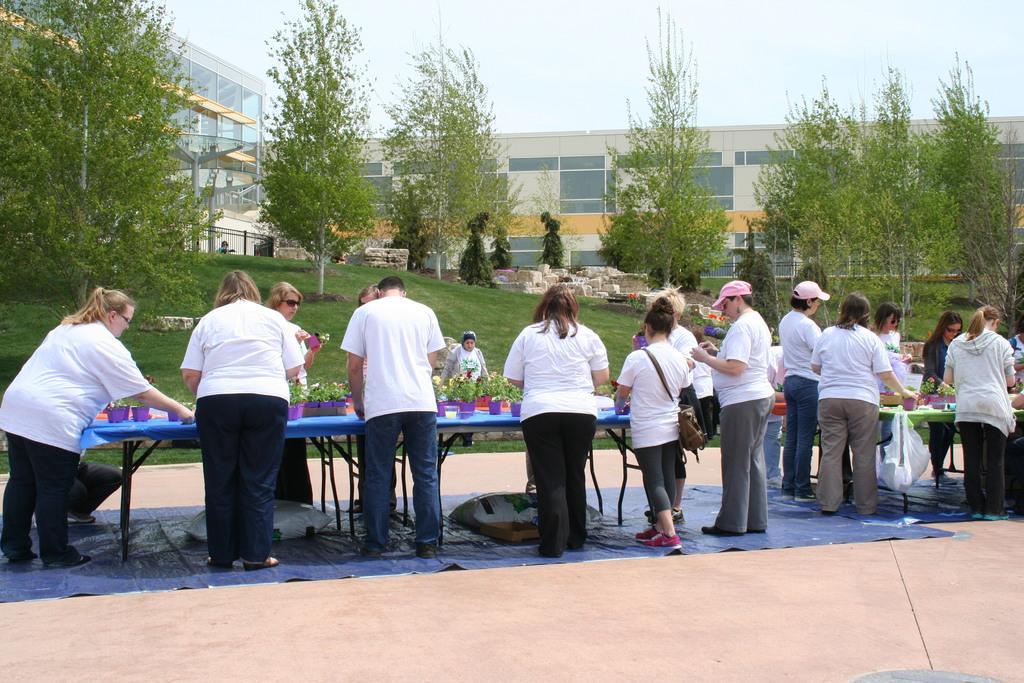Please provide a concise description of this image. In this image i can see a group of people are standing in front of a table and wearing a white tops. I can see there are few trees and building. 